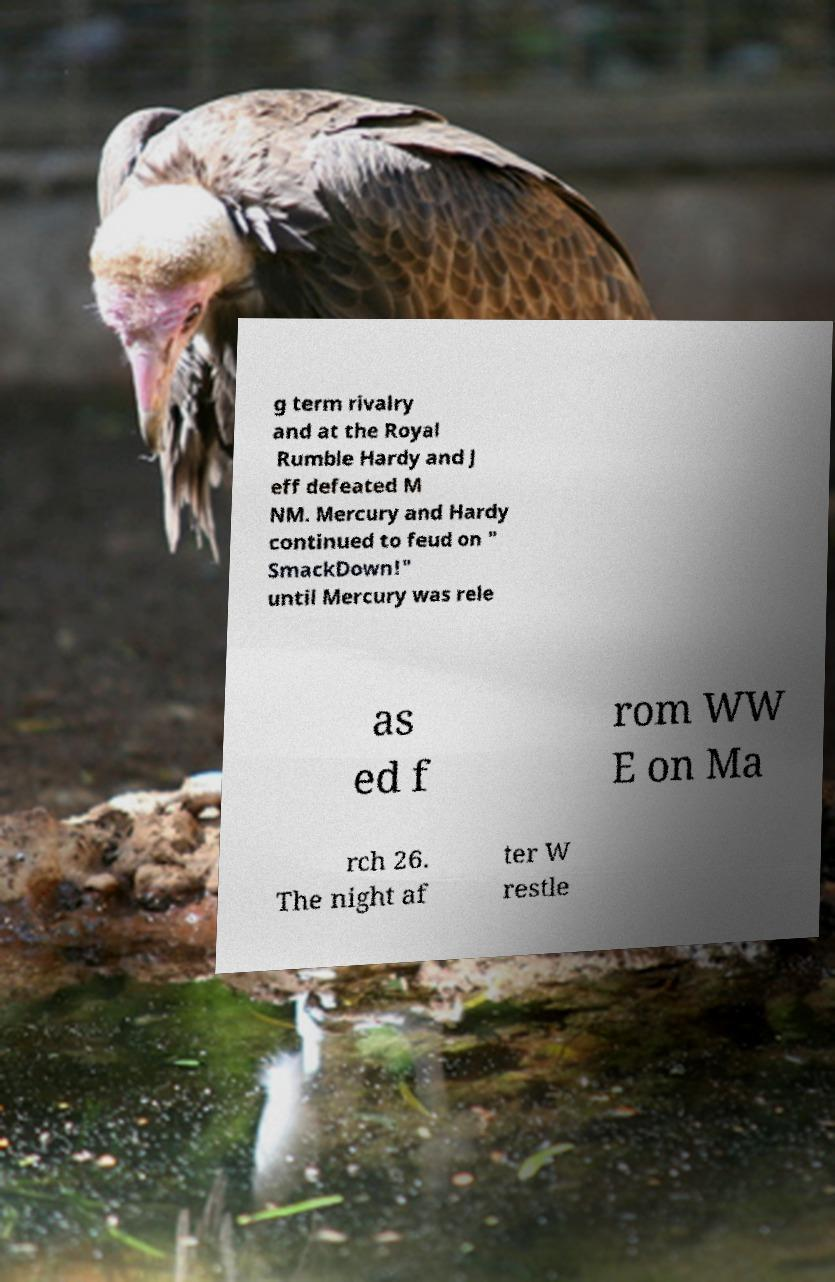I need the written content from this picture converted into text. Can you do that? g term rivalry and at the Royal Rumble Hardy and J eff defeated M NM. Mercury and Hardy continued to feud on " SmackDown!" until Mercury was rele as ed f rom WW E on Ma rch 26. The night af ter W restle 